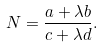<formula> <loc_0><loc_0><loc_500><loc_500>N = \frac { a + \lambda b } { c + \lambda d } .</formula> 